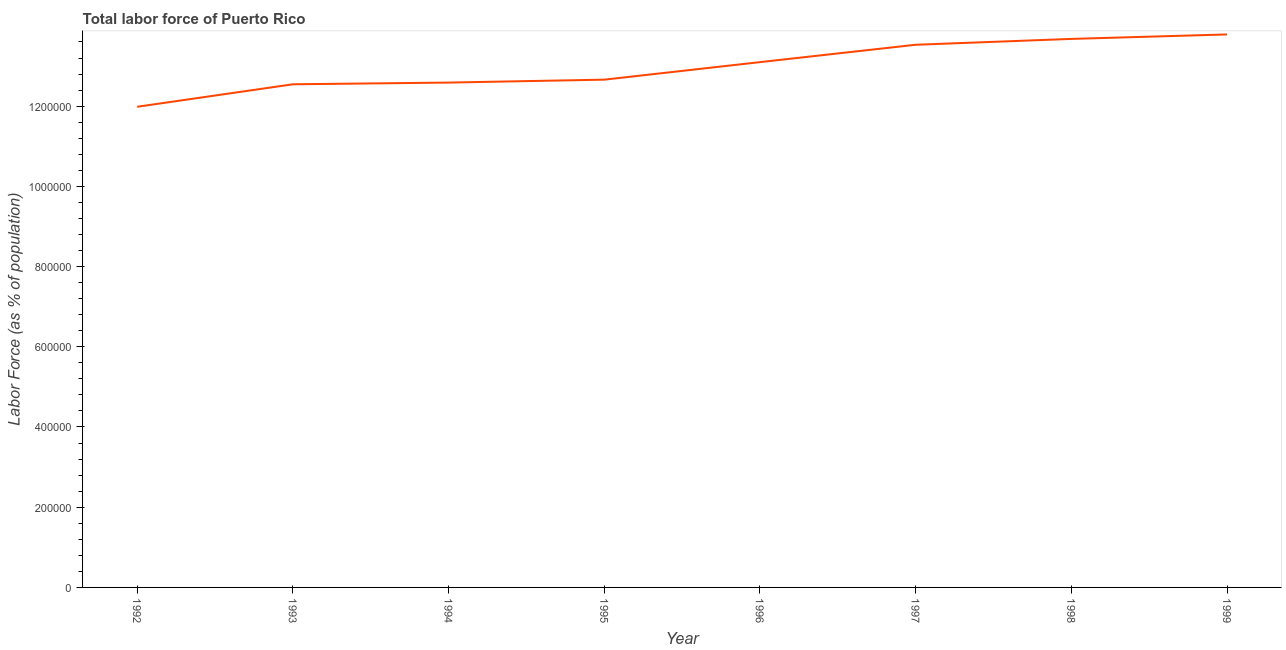What is the total labor force in 1998?
Offer a very short reply. 1.37e+06. Across all years, what is the maximum total labor force?
Give a very brief answer. 1.38e+06. Across all years, what is the minimum total labor force?
Give a very brief answer. 1.20e+06. In which year was the total labor force maximum?
Offer a terse response. 1999. What is the sum of the total labor force?
Keep it short and to the point. 1.04e+07. What is the difference between the total labor force in 1992 and 1994?
Your answer should be compact. -6.03e+04. What is the average total labor force per year?
Give a very brief answer. 1.30e+06. What is the median total labor force?
Make the answer very short. 1.29e+06. What is the ratio of the total labor force in 1992 to that in 1997?
Provide a succinct answer. 0.89. What is the difference between the highest and the second highest total labor force?
Ensure brevity in your answer.  1.11e+04. What is the difference between the highest and the lowest total labor force?
Your answer should be compact. 1.80e+05. Does the total labor force monotonically increase over the years?
Provide a short and direct response. Yes. How many lines are there?
Offer a very short reply. 1. How many years are there in the graph?
Offer a very short reply. 8. Are the values on the major ticks of Y-axis written in scientific E-notation?
Give a very brief answer. No. Does the graph contain grids?
Keep it short and to the point. No. What is the title of the graph?
Your response must be concise. Total labor force of Puerto Rico. What is the label or title of the Y-axis?
Provide a short and direct response. Labor Force (as % of population). What is the Labor Force (as % of population) in 1992?
Give a very brief answer. 1.20e+06. What is the Labor Force (as % of population) in 1993?
Offer a very short reply. 1.25e+06. What is the Labor Force (as % of population) of 1994?
Offer a very short reply. 1.26e+06. What is the Labor Force (as % of population) in 1995?
Make the answer very short. 1.27e+06. What is the Labor Force (as % of population) in 1996?
Keep it short and to the point. 1.31e+06. What is the Labor Force (as % of population) of 1997?
Ensure brevity in your answer.  1.35e+06. What is the Labor Force (as % of population) in 1998?
Keep it short and to the point. 1.37e+06. What is the Labor Force (as % of population) of 1999?
Make the answer very short. 1.38e+06. What is the difference between the Labor Force (as % of population) in 1992 and 1993?
Offer a very short reply. -5.61e+04. What is the difference between the Labor Force (as % of population) in 1992 and 1994?
Ensure brevity in your answer.  -6.03e+04. What is the difference between the Labor Force (as % of population) in 1992 and 1995?
Provide a succinct answer. -6.76e+04. What is the difference between the Labor Force (as % of population) in 1992 and 1996?
Your answer should be compact. -1.11e+05. What is the difference between the Labor Force (as % of population) in 1992 and 1997?
Your response must be concise. -1.55e+05. What is the difference between the Labor Force (as % of population) in 1992 and 1998?
Your response must be concise. -1.69e+05. What is the difference between the Labor Force (as % of population) in 1992 and 1999?
Ensure brevity in your answer.  -1.80e+05. What is the difference between the Labor Force (as % of population) in 1993 and 1994?
Your answer should be very brief. -4266. What is the difference between the Labor Force (as % of population) in 1993 and 1995?
Keep it short and to the point. -1.15e+04. What is the difference between the Labor Force (as % of population) in 1993 and 1996?
Provide a succinct answer. -5.52e+04. What is the difference between the Labor Force (as % of population) in 1993 and 1997?
Your answer should be very brief. -9.85e+04. What is the difference between the Labor Force (as % of population) in 1993 and 1998?
Your answer should be compact. -1.13e+05. What is the difference between the Labor Force (as % of population) in 1993 and 1999?
Your response must be concise. -1.24e+05. What is the difference between the Labor Force (as % of population) in 1994 and 1995?
Offer a terse response. -7260. What is the difference between the Labor Force (as % of population) in 1994 and 1996?
Provide a succinct answer. -5.10e+04. What is the difference between the Labor Force (as % of population) in 1994 and 1997?
Keep it short and to the point. -9.43e+04. What is the difference between the Labor Force (as % of population) in 1994 and 1998?
Offer a very short reply. -1.09e+05. What is the difference between the Labor Force (as % of population) in 1994 and 1999?
Your answer should be very brief. -1.20e+05. What is the difference between the Labor Force (as % of population) in 1995 and 1996?
Your answer should be very brief. -4.37e+04. What is the difference between the Labor Force (as % of population) in 1995 and 1997?
Make the answer very short. -8.70e+04. What is the difference between the Labor Force (as % of population) in 1995 and 1998?
Keep it short and to the point. -1.02e+05. What is the difference between the Labor Force (as % of population) in 1995 and 1999?
Your answer should be compact. -1.13e+05. What is the difference between the Labor Force (as % of population) in 1996 and 1997?
Provide a short and direct response. -4.33e+04. What is the difference between the Labor Force (as % of population) in 1996 and 1998?
Offer a terse response. -5.79e+04. What is the difference between the Labor Force (as % of population) in 1996 and 1999?
Offer a terse response. -6.90e+04. What is the difference between the Labor Force (as % of population) in 1997 and 1998?
Give a very brief answer. -1.46e+04. What is the difference between the Labor Force (as % of population) in 1997 and 1999?
Offer a terse response. -2.57e+04. What is the difference between the Labor Force (as % of population) in 1998 and 1999?
Offer a very short reply. -1.11e+04. What is the ratio of the Labor Force (as % of population) in 1992 to that in 1993?
Your answer should be very brief. 0.95. What is the ratio of the Labor Force (as % of population) in 1992 to that in 1994?
Give a very brief answer. 0.95. What is the ratio of the Labor Force (as % of population) in 1992 to that in 1995?
Provide a succinct answer. 0.95. What is the ratio of the Labor Force (as % of population) in 1992 to that in 1996?
Keep it short and to the point. 0.92. What is the ratio of the Labor Force (as % of population) in 1992 to that in 1997?
Your response must be concise. 0.89. What is the ratio of the Labor Force (as % of population) in 1992 to that in 1998?
Give a very brief answer. 0.88. What is the ratio of the Labor Force (as % of population) in 1992 to that in 1999?
Give a very brief answer. 0.87. What is the ratio of the Labor Force (as % of population) in 1993 to that in 1994?
Give a very brief answer. 1. What is the ratio of the Labor Force (as % of population) in 1993 to that in 1995?
Your answer should be compact. 0.99. What is the ratio of the Labor Force (as % of population) in 1993 to that in 1996?
Offer a terse response. 0.96. What is the ratio of the Labor Force (as % of population) in 1993 to that in 1997?
Offer a terse response. 0.93. What is the ratio of the Labor Force (as % of population) in 1993 to that in 1998?
Ensure brevity in your answer.  0.92. What is the ratio of the Labor Force (as % of population) in 1993 to that in 1999?
Your answer should be very brief. 0.91. What is the ratio of the Labor Force (as % of population) in 1994 to that in 1995?
Your response must be concise. 0.99. What is the ratio of the Labor Force (as % of population) in 1994 to that in 1999?
Provide a succinct answer. 0.91. What is the ratio of the Labor Force (as % of population) in 1995 to that in 1996?
Ensure brevity in your answer.  0.97. What is the ratio of the Labor Force (as % of population) in 1995 to that in 1997?
Offer a terse response. 0.94. What is the ratio of the Labor Force (as % of population) in 1995 to that in 1998?
Offer a terse response. 0.93. What is the ratio of the Labor Force (as % of population) in 1995 to that in 1999?
Your answer should be very brief. 0.92. What is the ratio of the Labor Force (as % of population) in 1996 to that in 1998?
Your response must be concise. 0.96. What is the ratio of the Labor Force (as % of population) in 1996 to that in 1999?
Provide a short and direct response. 0.95. What is the ratio of the Labor Force (as % of population) in 1997 to that in 1999?
Your answer should be compact. 0.98. What is the ratio of the Labor Force (as % of population) in 1998 to that in 1999?
Give a very brief answer. 0.99. 